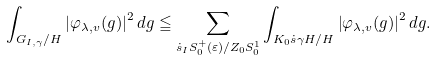<formula> <loc_0><loc_0><loc_500><loc_500>\int _ { G _ { I , \gamma } / H } \left | \varphi _ { \lambda , v } ( g ) \right | ^ { 2 } d g \leqq \sum _ { \dot { s } _ { I } S _ { 0 } ^ { + } ( \varepsilon ) / Z _ { 0 } S _ { 0 } ^ { 1 } } \int _ { K _ { 0 } \dot { s } \gamma H / H } \left | \varphi _ { \lambda , v } ( g ) \right | ^ { 2 } d g .</formula> 